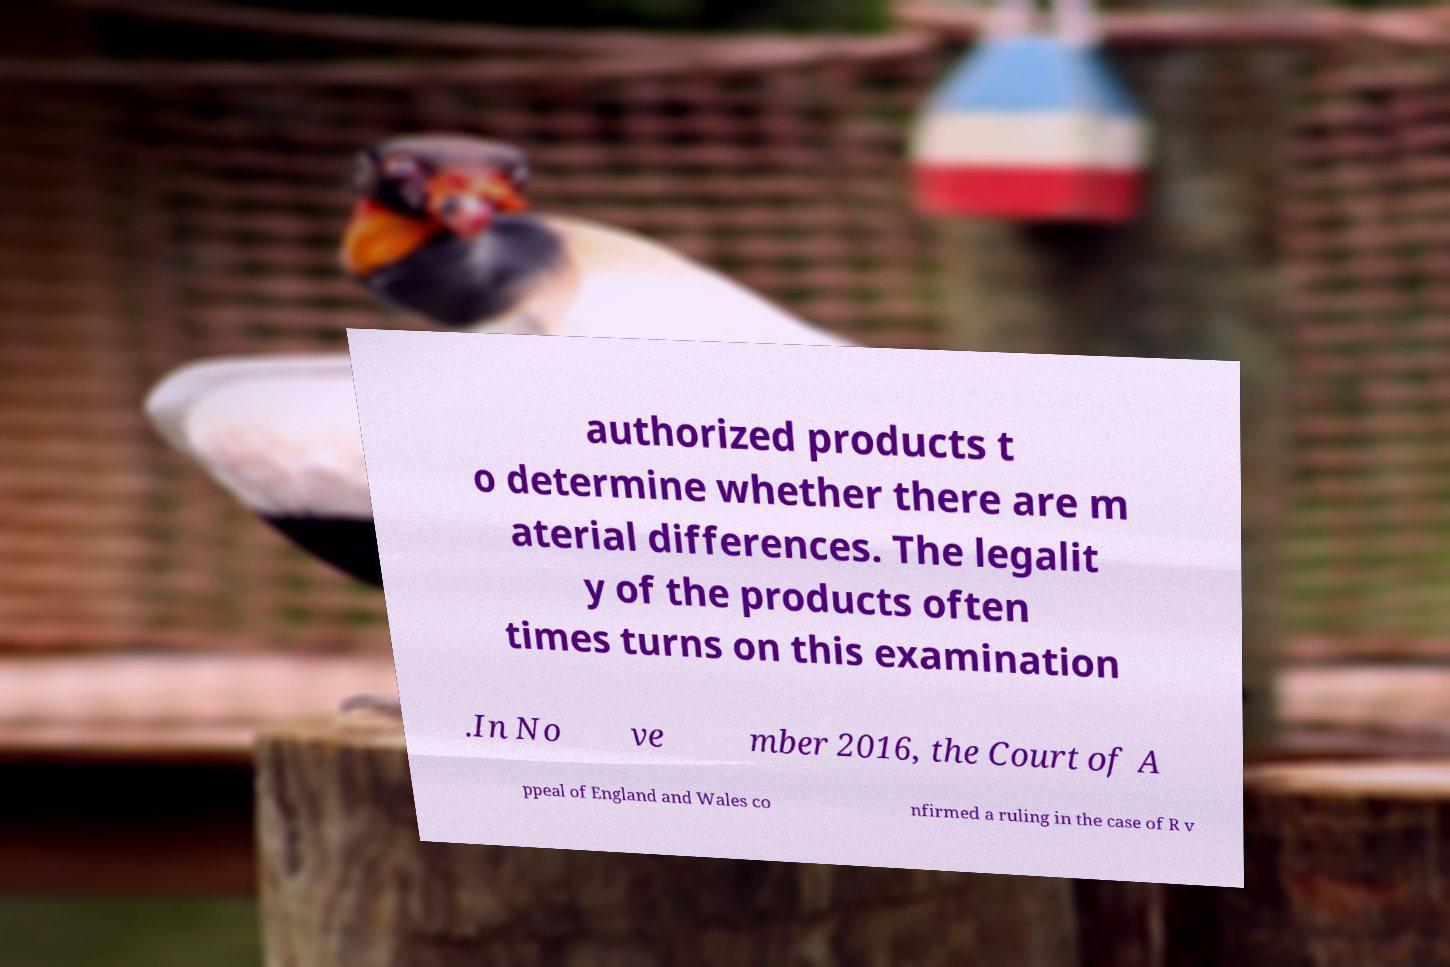There's text embedded in this image that I need extracted. Can you transcribe it verbatim? authorized products t o determine whether there are m aterial differences. The legalit y of the products often times turns on this examination .In No ve mber 2016, the Court of A ppeal of England and Wales co nfirmed a ruling in the case of R v 